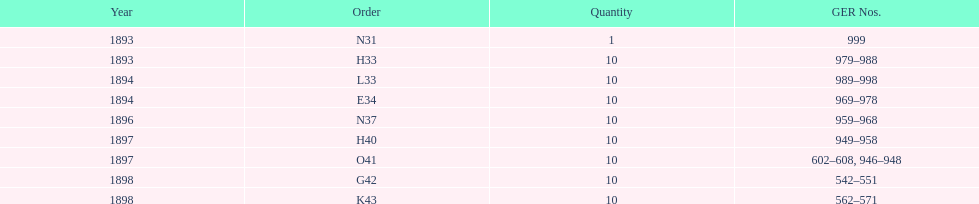Between 1893 and 1898, which year was devoid of an order? 1895. 